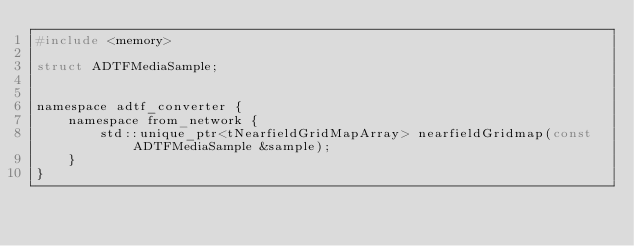<code> <loc_0><loc_0><loc_500><loc_500><_C_>#include <memory>

struct ADTFMediaSample;


namespace adtf_converter {
    namespace from_network {
        std::unique_ptr<tNearfieldGridMapArray> nearfieldGridmap(const ADTFMediaSample &sample);
    }
}
</code> 